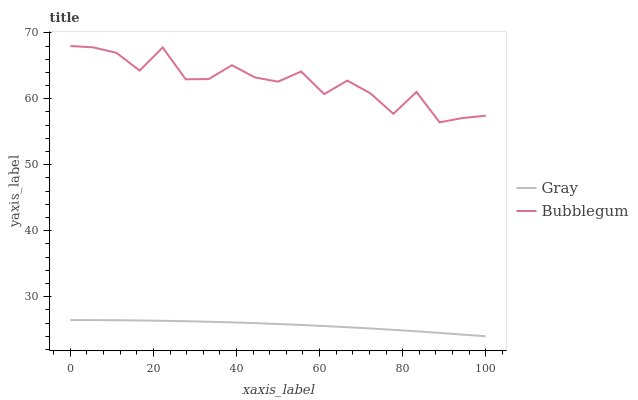Does Bubblegum have the minimum area under the curve?
Answer yes or no. No. Is Bubblegum the smoothest?
Answer yes or no. No. Does Bubblegum have the lowest value?
Answer yes or no. No. Is Gray less than Bubblegum?
Answer yes or no. Yes. Is Bubblegum greater than Gray?
Answer yes or no. Yes. Does Gray intersect Bubblegum?
Answer yes or no. No. 